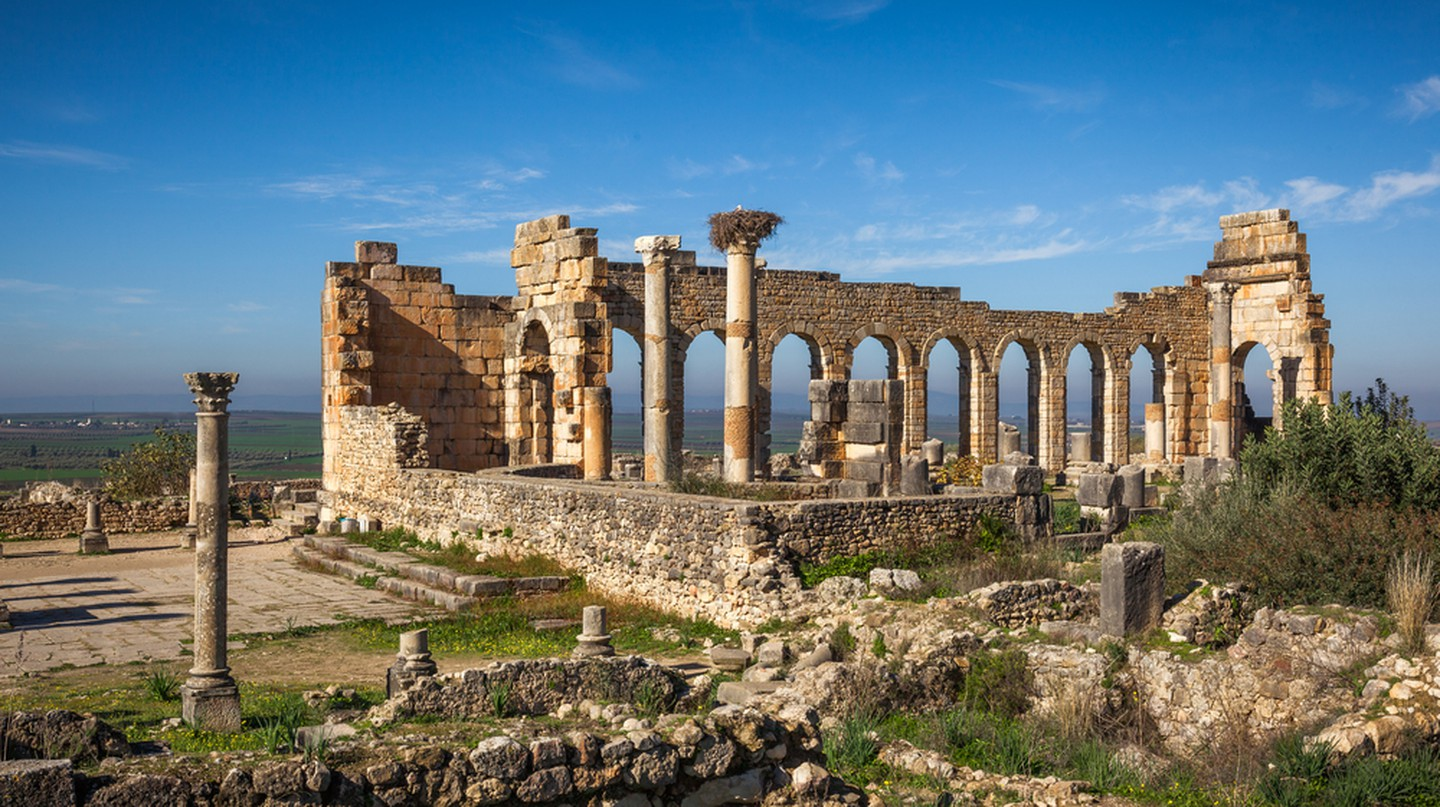What historical events are associated with these ruins? Volubilis was once a major Roman outpost and experienced various significant historical events. Established before the Roman conquest, it grew significantly under Roman rule from the 1st century AD. The city was part of the Roman Empire's expansion into North Africa, serving as a key administrative and economic center. After the fall of Rome, the site was not abandoned. It remained inhabited for centuries, witnessing transitions through Islamic rule and was only abandoned in the 11th century following the relocation of the region's capital to nearby Fes. 